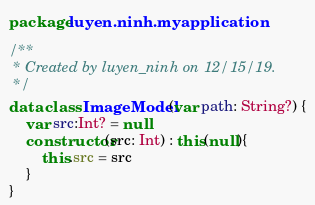<code> <loc_0><loc_0><loc_500><loc_500><_Kotlin_>package luyen.ninh.myapplication

/**
 * Created by luyen_ninh on 12/15/19.
 */
data class ImageModel(var path: String?) {
    var src:Int? = null
    constructor(src: Int) : this(null){
        this.src = src
    }
}</code> 